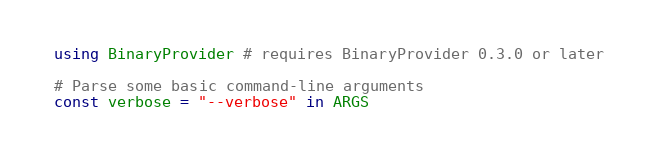Convert code to text. <code><loc_0><loc_0><loc_500><loc_500><_Julia_>using BinaryProvider # requires BinaryProvider 0.3.0 or later

# Parse some basic command-line arguments
const verbose = "--verbose" in ARGS</code> 